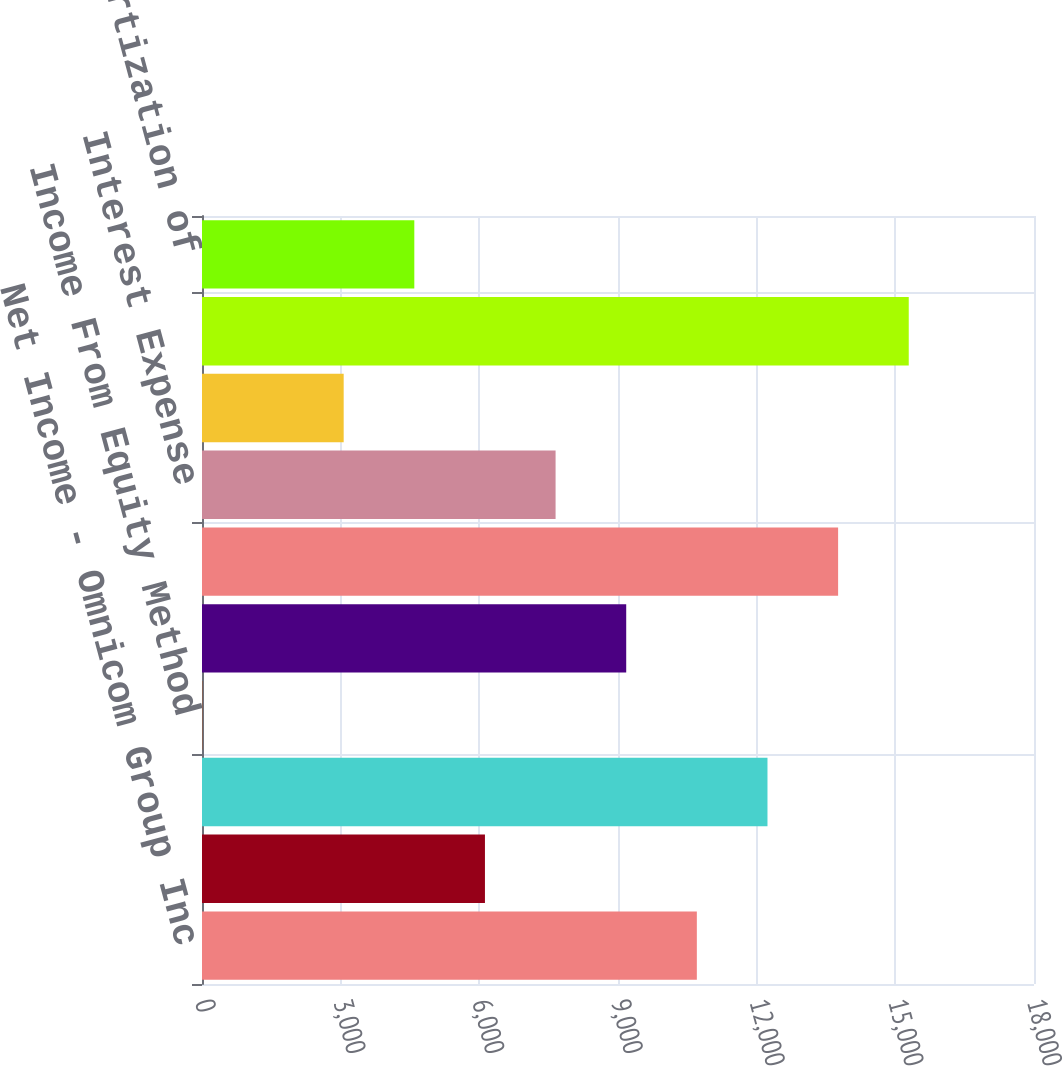<chart> <loc_0><loc_0><loc_500><loc_500><bar_chart><fcel>Net Income - Omnicom Group Inc<fcel>Net Income Attributed To<fcel>Net Income<fcel>Income From Equity Method<fcel>Income Tax Expense<fcel>Income Before Income Taxes and<fcel>Interest Expense<fcel>Interest Income<fcel>Operating Profit<fcel>Add back Amortization of<nl><fcel>10705.8<fcel>6121.42<fcel>12233.9<fcel>8.9<fcel>9177.68<fcel>13762.1<fcel>7649.55<fcel>3065.16<fcel>15290.2<fcel>4593.29<nl></chart> 